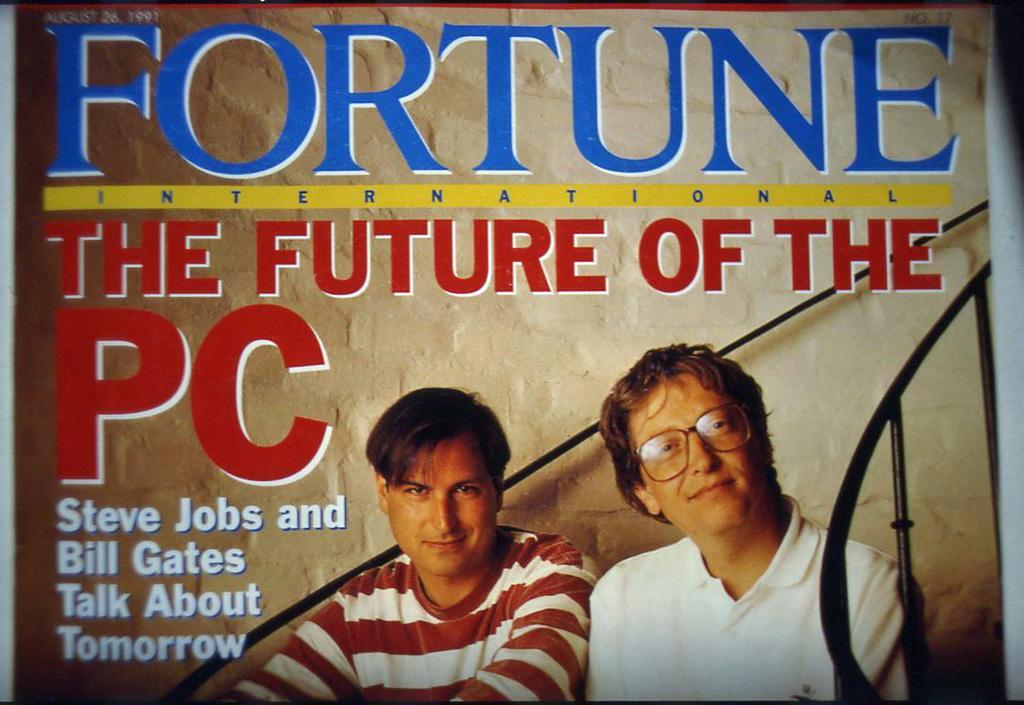Can you describe this image briefly? In this picture I can see a poster, there are words, numbers and there is an image of two persons on the poster. 